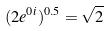<formula> <loc_0><loc_0><loc_500><loc_500>( 2 e ^ { 0 i } ) ^ { 0 . 5 } = \sqrt { 2 }</formula> 